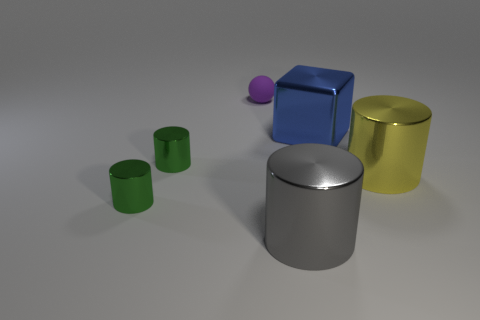What number of other objects are the same shape as the gray metallic object?
Your response must be concise. 3. There is a matte object that is left of the gray shiny thing in front of the shiny object on the right side of the shiny block; what is its size?
Provide a short and direct response. Small. Is the number of small rubber spheres that are behind the big blue cube greater than the number of big brown metallic balls?
Provide a short and direct response. Yes. Are any big gray cylinders visible?
Make the answer very short. Yes. How many spheres have the same size as the blue metal block?
Make the answer very short. 0. Are there more large things on the right side of the small purple rubber thing than large metallic cylinders to the right of the big yellow shiny cylinder?
Your response must be concise. Yes. There is a gray cylinder that is the same size as the blue thing; what is its material?
Make the answer very short. Metal. What is the shape of the purple matte thing?
Provide a short and direct response. Sphere. What number of gray things are tiny spheres or big metallic blocks?
Your response must be concise. 0. What is the size of the yellow cylinder that is the same material as the large blue object?
Offer a terse response. Large. 